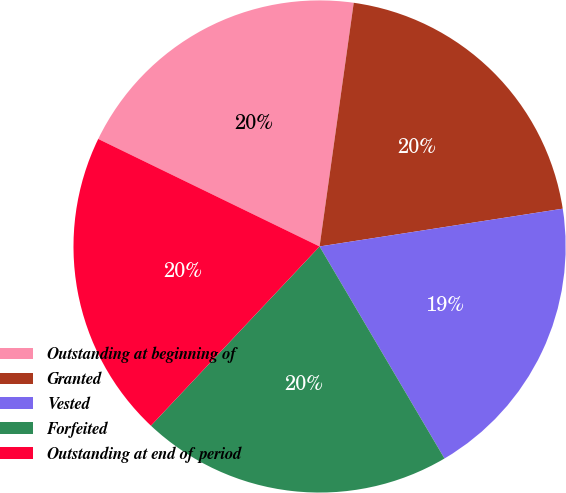Convert chart. <chart><loc_0><loc_0><loc_500><loc_500><pie_chart><fcel>Outstanding at beginning of<fcel>Granted<fcel>Vested<fcel>Forfeited<fcel>Outstanding at end of period<nl><fcel>20.02%<fcel>20.33%<fcel>18.98%<fcel>20.49%<fcel>20.18%<nl></chart> 